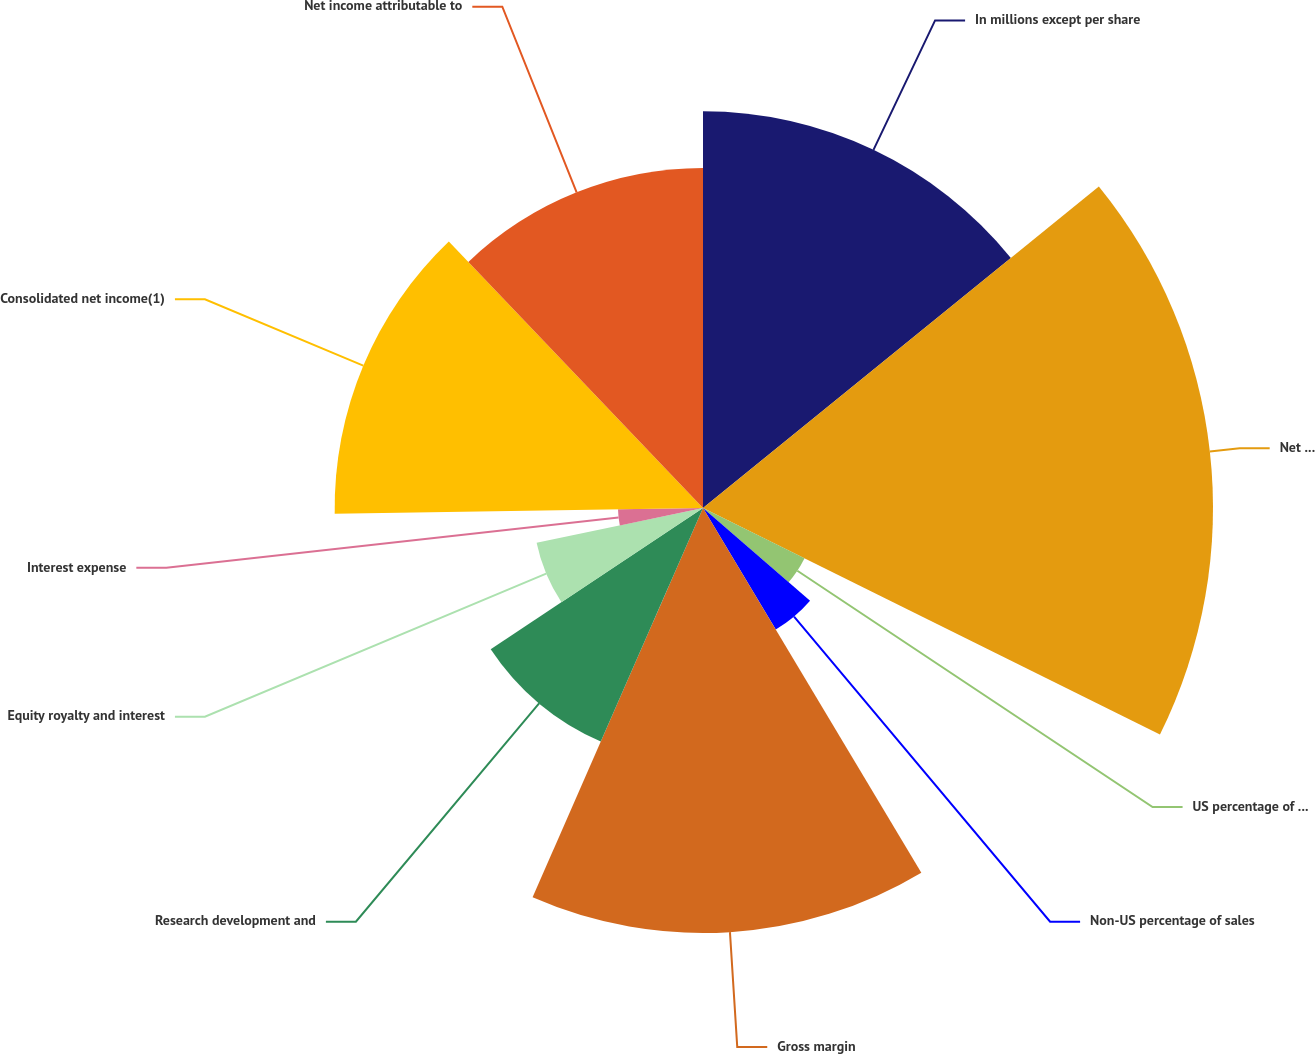<chart> <loc_0><loc_0><loc_500><loc_500><pie_chart><fcel>In millions except per share<fcel>Net sales<fcel>US percentage of sales<fcel>Non-US percentage of sales<fcel>Gross margin<fcel>Research development and<fcel>Equity royalty and interest<fcel>Interest expense<fcel>Consolidated net income(1)<fcel>Net income attributable to<nl><fcel>14.14%<fcel>18.18%<fcel>4.04%<fcel>5.05%<fcel>15.15%<fcel>9.09%<fcel>6.06%<fcel>3.03%<fcel>13.13%<fcel>12.12%<nl></chart> 